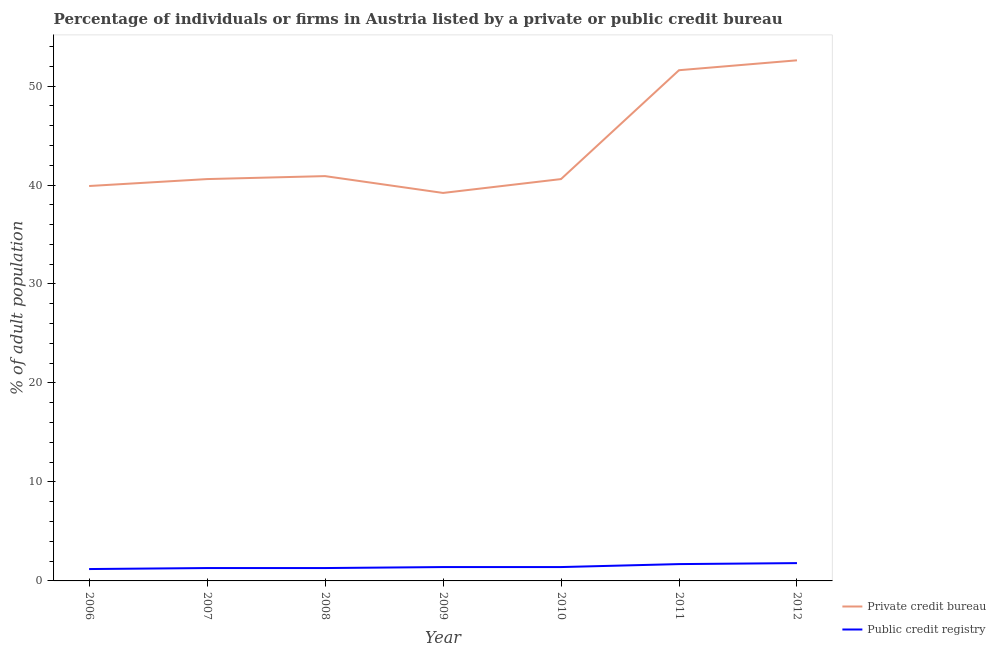How many different coloured lines are there?
Offer a terse response. 2. Is the number of lines equal to the number of legend labels?
Make the answer very short. Yes. Across all years, what is the maximum percentage of firms listed by private credit bureau?
Keep it short and to the point. 52.6. Across all years, what is the minimum percentage of firms listed by public credit bureau?
Keep it short and to the point. 1.2. In which year was the percentage of firms listed by private credit bureau maximum?
Keep it short and to the point. 2012. What is the total percentage of firms listed by private credit bureau in the graph?
Offer a terse response. 305.4. What is the difference between the percentage of firms listed by public credit bureau in 2008 and that in 2009?
Make the answer very short. -0.1. What is the difference between the percentage of firms listed by private credit bureau in 2011 and the percentage of firms listed by public credit bureau in 2009?
Your response must be concise. 50.2. What is the average percentage of firms listed by private credit bureau per year?
Offer a very short reply. 43.63. In the year 2007, what is the difference between the percentage of firms listed by public credit bureau and percentage of firms listed by private credit bureau?
Your response must be concise. -39.3. What is the ratio of the percentage of firms listed by private credit bureau in 2009 to that in 2011?
Make the answer very short. 0.76. Is the percentage of firms listed by public credit bureau in 2007 less than that in 2012?
Your answer should be very brief. Yes. Is the difference between the percentage of firms listed by public credit bureau in 2008 and 2011 greater than the difference between the percentage of firms listed by private credit bureau in 2008 and 2011?
Provide a short and direct response. Yes. What is the difference between the highest and the second highest percentage of firms listed by public credit bureau?
Ensure brevity in your answer.  0.1. What is the difference between the highest and the lowest percentage of firms listed by public credit bureau?
Your answer should be very brief. 0.6. In how many years, is the percentage of firms listed by public credit bureau greater than the average percentage of firms listed by public credit bureau taken over all years?
Give a very brief answer. 2. Does the percentage of firms listed by private credit bureau monotonically increase over the years?
Offer a very short reply. No. Is the percentage of firms listed by private credit bureau strictly greater than the percentage of firms listed by public credit bureau over the years?
Your answer should be very brief. Yes. How many lines are there?
Your answer should be very brief. 2. What is the difference between two consecutive major ticks on the Y-axis?
Keep it short and to the point. 10. Are the values on the major ticks of Y-axis written in scientific E-notation?
Your response must be concise. No. Does the graph contain grids?
Keep it short and to the point. No. How many legend labels are there?
Keep it short and to the point. 2. How are the legend labels stacked?
Provide a short and direct response. Vertical. What is the title of the graph?
Make the answer very short. Percentage of individuals or firms in Austria listed by a private or public credit bureau. What is the label or title of the X-axis?
Ensure brevity in your answer.  Year. What is the label or title of the Y-axis?
Offer a terse response. % of adult population. What is the % of adult population in Private credit bureau in 2006?
Keep it short and to the point. 39.9. What is the % of adult population of Private credit bureau in 2007?
Ensure brevity in your answer.  40.6. What is the % of adult population of Public credit registry in 2007?
Your answer should be very brief. 1.3. What is the % of adult population of Private credit bureau in 2008?
Your answer should be compact. 40.9. What is the % of adult population of Private credit bureau in 2009?
Offer a terse response. 39.2. What is the % of adult population of Public credit registry in 2009?
Provide a short and direct response. 1.4. What is the % of adult population of Private credit bureau in 2010?
Your answer should be very brief. 40.6. What is the % of adult population in Public credit registry in 2010?
Keep it short and to the point. 1.4. What is the % of adult population of Private credit bureau in 2011?
Your response must be concise. 51.6. What is the % of adult population in Private credit bureau in 2012?
Ensure brevity in your answer.  52.6. Across all years, what is the maximum % of adult population of Private credit bureau?
Provide a short and direct response. 52.6. Across all years, what is the maximum % of adult population in Public credit registry?
Ensure brevity in your answer.  1.8. Across all years, what is the minimum % of adult population of Private credit bureau?
Keep it short and to the point. 39.2. What is the total % of adult population in Private credit bureau in the graph?
Offer a terse response. 305.4. What is the total % of adult population in Public credit registry in the graph?
Provide a succinct answer. 10.1. What is the difference between the % of adult population in Private credit bureau in 2006 and that in 2007?
Your response must be concise. -0.7. What is the difference between the % of adult population of Public credit registry in 2006 and that in 2007?
Your answer should be compact. -0.1. What is the difference between the % of adult population in Private credit bureau in 2006 and that in 2008?
Ensure brevity in your answer.  -1. What is the difference between the % of adult population in Private credit bureau in 2006 and that in 2009?
Offer a very short reply. 0.7. What is the difference between the % of adult population in Public credit registry in 2006 and that in 2010?
Provide a succinct answer. -0.2. What is the difference between the % of adult population of Public credit registry in 2006 and that in 2012?
Keep it short and to the point. -0.6. What is the difference between the % of adult population of Private credit bureau in 2007 and that in 2009?
Your response must be concise. 1.4. What is the difference between the % of adult population of Public credit registry in 2007 and that in 2010?
Provide a short and direct response. -0.1. What is the difference between the % of adult population in Public credit registry in 2007 and that in 2012?
Ensure brevity in your answer.  -0.5. What is the difference between the % of adult population of Private credit bureau in 2008 and that in 2009?
Your answer should be very brief. 1.7. What is the difference between the % of adult population of Public credit registry in 2008 and that in 2009?
Your answer should be very brief. -0.1. What is the difference between the % of adult population in Private credit bureau in 2008 and that in 2010?
Make the answer very short. 0.3. What is the difference between the % of adult population in Public credit registry in 2008 and that in 2010?
Offer a very short reply. -0.1. What is the difference between the % of adult population in Private credit bureau in 2008 and that in 2011?
Make the answer very short. -10.7. What is the difference between the % of adult population in Public credit registry in 2008 and that in 2011?
Provide a succinct answer. -0.4. What is the difference between the % of adult population of Private credit bureau in 2008 and that in 2012?
Provide a succinct answer. -11.7. What is the difference between the % of adult population of Public credit registry in 2008 and that in 2012?
Provide a short and direct response. -0.5. What is the difference between the % of adult population in Private credit bureau in 2009 and that in 2010?
Keep it short and to the point. -1.4. What is the difference between the % of adult population of Public credit registry in 2009 and that in 2010?
Give a very brief answer. 0. What is the difference between the % of adult population of Private credit bureau in 2009 and that in 2012?
Give a very brief answer. -13.4. What is the difference between the % of adult population in Public credit registry in 2009 and that in 2012?
Offer a terse response. -0.4. What is the difference between the % of adult population in Private credit bureau in 2010 and that in 2011?
Offer a terse response. -11. What is the difference between the % of adult population of Public credit registry in 2010 and that in 2011?
Provide a succinct answer. -0.3. What is the difference between the % of adult population of Private credit bureau in 2006 and the % of adult population of Public credit registry in 2007?
Make the answer very short. 38.6. What is the difference between the % of adult population of Private credit bureau in 2006 and the % of adult population of Public credit registry in 2008?
Give a very brief answer. 38.6. What is the difference between the % of adult population of Private credit bureau in 2006 and the % of adult population of Public credit registry in 2009?
Your response must be concise. 38.5. What is the difference between the % of adult population in Private credit bureau in 2006 and the % of adult population in Public credit registry in 2010?
Your answer should be compact. 38.5. What is the difference between the % of adult population of Private credit bureau in 2006 and the % of adult population of Public credit registry in 2011?
Give a very brief answer. 38.2. What is the difference between the % of adult population in Private credit bureau in 2006 and the % of adult population in Public credit registry in 2012?
Your response must be concise. 38.1. What is the difference between the % of adult population of Private credit bureau in 2007 and the % of adult population of Public credit registry in 2008?
Offer a very short reply. 39.3. What is the difference between the % of adult population of Private credit bureau in 2007 and the % of adult population of Public credit registry in 2009?
Offer a very short reply. 39.2. What is the difference between the % of adult population of Private credit bureau in 2007 and the % of adult population of Public credit registry in 2010?
Give a very brief answer. 39.2. What is the difference between the % of adult population of Private credit bureau in 2007 and the % of adult population of Public credit registry in 2011?
Your answer should be compact. 38.9. What is the difference between the % of adult population in Private credit bureau in 2007 and the % of adult population in Public credit registry in 2012?
Offer a terse response. 38.8. What is the difference between the % of adult population of Private credit bureau in 2008 and the % of adult population of Public credit registry in 2009?
Your response must be concise. 39.5. What is the difference between the % of adult population in Private credit bureau in 2008 and the % of adult population in Public credit registry in 2010?
Give a very brief answer. 39.5. What is the difference between the % of adult population in Private credit bureau in 2008 and the % of adult population in Public credit registry in 2011?
Offer a very short reply. 39.2. What is the difference between the % of adult population in Private credit bureau in 2008 and the % of adult population in Public credit registry in 2012?
Make the answer very short. 39.1. What is the difference between the % of adult population in Private credit bureau in 2009 and the % of adult population in Public credit registry in 2010?
Provide a succinct answer. 37.8. What is the difference between the % of adult population of Private credit bureau in 2009 and the % of adult population of Public credit registry in 2011?
Your response must be concise. 37.5. What is the difference between the % of adult population in Private credit bureau in 2009 and the % of adult population in Public credit registry in 2012?
Offer a terse response. 37.4. What is the difference between the % of adult population in Private credit bureau in 2010 and the % of adult population in Public credit registry in 2011?
Your response must be concise. 38.9. What is the difference between the % of adult population in Private credit bureau in 2010 and the % of adult population in Public credit registry in 2012?
Provide a succinct answer. 38.8. What is the difference between the % of adult population in Private credit bureau in 2011 and the % of adult population in Public credit registry in 2012?
Provide a succinct answer. 49.8. What is the average % of adult population in Private credit bureau per year?
Offer a very short reply. 43.63. What is the average % of adult population of Public credit registry per year?
Give a very brief answer. 1.44. In the year 2006, what is the difference between the % of adult population in Private credit bureau and % of adult population in Public credit registry?
Offer a terse response. 38.7. In the year 2007, what is the difference between the % of adult population of Private credit bureau and % of adult population of Public credit registry?
Ensure brevity in your answer.  39.3. In the year 2008, what is the difference between the % of adult population of Private credit bureau and % of adult population of Public credit registry?
Ensure brevity in your answer.  39.6. In the year 2009, what is the difference between the % of adult population in Private credit bureau and % of adult population in Public credit registry?
Ensure brevity in your answer.  37.8. In the year 2010, what is the difference between the % of adult population of Private credit bureau and % of adult population of Public credit registry?
Give a very brief answer. 39.2. In the year 2011, what is the difference between the % of adult population in Private credit bureau and % of adult population in Public credit registry?
Make the answer very short. 49.9. In the year 2012, what is the difference between the % of adult population of Private credit bureau and % of adult population of Public credit registry?
Your answer should be very brief. 50.8. What is the ratio of the % of adult population of Private credit bureau in 2006 to that in 2007?
Offer a very short reply. 0.98. What is the ratio of the % of adult population of Private credit bureau in 2006 to that in 2008?
Offer a very short reply. 0.98. What is the ratio of the % of adult population in Private credit bureau in 2006 to that in 2009?
Offer a very short reply. 1.02. What is the ratio of the % of adult population in Private credit bureau in 2006 to that in 2010?
Your answer should be compact. 0.98. What is the ratio of the % of adult population in Public credit registry in 2006 to that in 2010?
Make the answer very short. 0.86. What is the ratio of the % of adult population of Private credit bureau in 2006 to that in 2011?
Provide a succinct answer. 0.77. What is the ratio of the % of adult population in Public credit registry in 2006 to that in 2011?
Your answer should be very brief. 0.71. What is the ratio of the % of adult population in Private credit bureau in 2006 to that in 2012?
Your response must be concise. 0.76. What is the ratio of the % of adult population in Public credit registry in 2006 to that in 2012?
Ensure brevity in your answer.  0.67. What is the ratio of the % of adult population in Private credit bureau in 2007 to that in 2008?
Give a very brief answer. 0.99. What is the ratio of the % of adult population in Public credit registry in 2007 to that in 2008?
Make the answer very short. 1. What is the ratio of the % of adult population of Private credit bureau in 2007 to that in 2009?
Give a very brief answer. 1.04. What is the ratio of the % of adult population in Private credit bureau in 2007 to that in 2010?
Your response must be concise. 1. What is the ratio of the % of adult population in Public credit registry in 2007 to that in 2010?
Your answer should be compact. 0.93. What is the ratio of the % of adult population in Private credit bureau in 2007 to that in 2011?
Make the answer very short. 0.79. What is the ratio of the % of adult population in Public credit registry in 2007 to that in 2011?
Give a very brief answer. 0.76. What is the ratio of the % of adult population in Private credit bureau in 2007 to that in 2012?
Make the answer very short. 0.77. What is the ratio of the % of adult population in Public credit registry in 2007 to that in 2012?
Your answer should be very brief. 0.72. What is the ratio of the % of adult population in Private credit bureau in 2008 to that in 2009?
Your answer should be compact. 1.04. What is the ratio of the % of adult population of Public credit registry in 2008 to that in 2009?
Make the answer very short. 0.93. What is the ratio of the % of adult population in Private credit bureau in 2008 to that in 2010?
Offer a very short reply. 1.01. What is the ratio of the % of adult population of Private credit bureau in 2008 to that in 2011?
Your response must be concise. 0.79. What is the ratio of the % of adult population of Public credit registry in 2008 to that in 2011?
Offer a very short reply. 0.76. What is the ratio of the % of adult population of Private credit bureau in 2008 to that in 2012?
Ensure brevity in your answer.  0.78. What is the ratio of the % of adult population in Public credit registry in 2008 to that in 2012?
Your response must be concise. 0.72. What is the ratio of the % of adult population in Private credit bureau in 2009 to that in 2010?
Make the answer very short. 0.97. What is the ratio of the % of adult population of Public credit registry in 2009 to that in 2010?
Offer a terse response. 1. What is the ratio of the % of adult population of Private credit bureau in 2009 to that in 2011?
Offer a terse response. 0.76. What is the ratio of the % of adult population of Public credit registry in 2009 to that in 2011?
Ensure brevity in your answer.  0.82. What is the ratio of the % of adult population of Private credit bureau in 2009 to that in 2012?
Ensure brevity in your answer.  0.75. What is the ratio of the % of adult population in Private credit bureau in 2010 to that in 2011?
Your answer should be very brief. 0.79. What is the ratio of the % of adult population of Public credit registry in 2010 to that in 2011?
Offer a very short reply. 0.82. What is the ratio of the % of adult population of Private credit bureau in 2010 to that in 2012?
Give a very brief answer. 0.77. What is the difference between the highest and the second highest % of adult population in Private credit bureau?
Your answer should be very brief. 1. What is the difference between the highest and the lowest % of adult population of Public credit registry?
Make the answer very short. 0.6. 